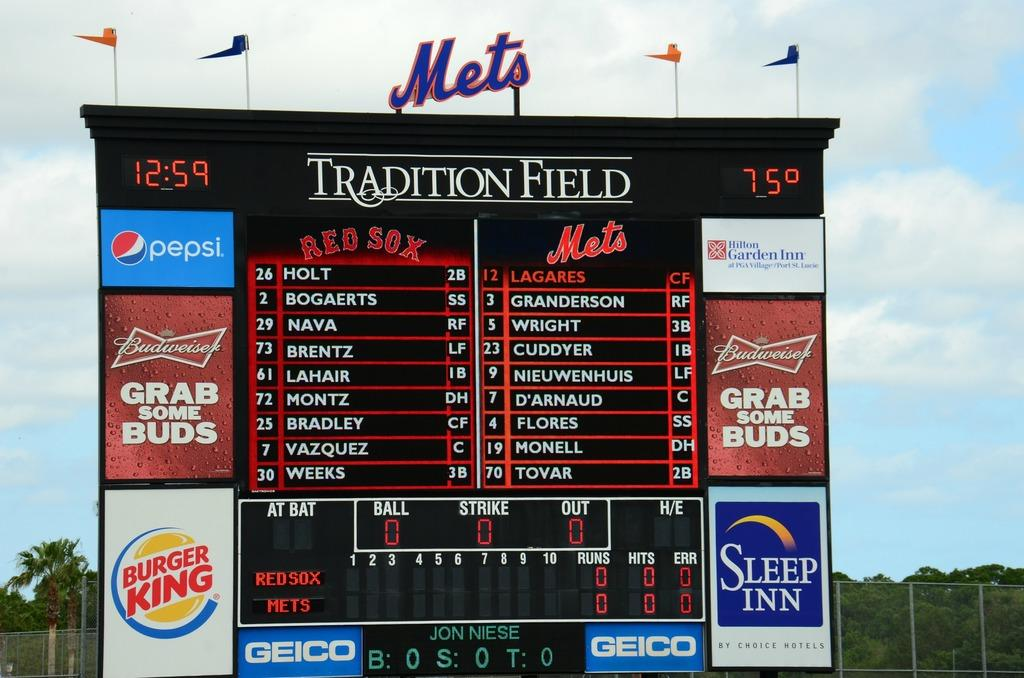<image>
Summarize the visual content of the image. Mets stadium jumbo tron screen that says 12:59 and 75 degrees, Mets are playing Red Sox at Tradition Field. 